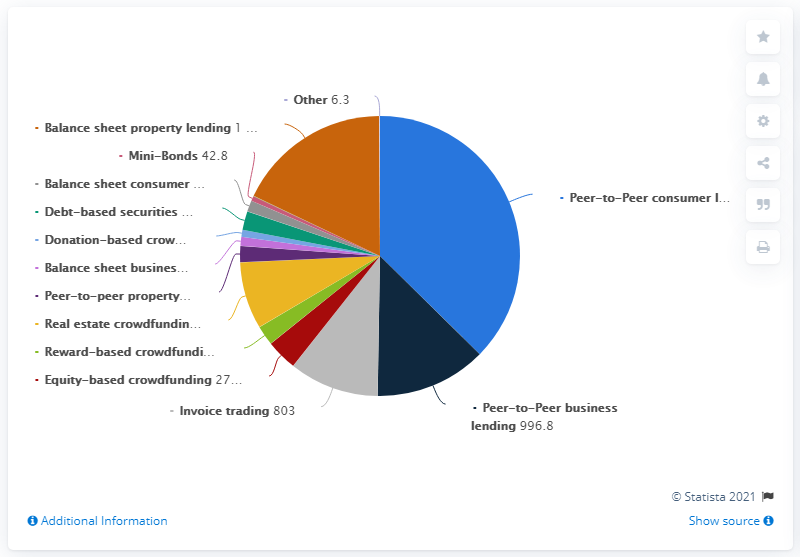Give some essential details in this illustration. The total value of transactions in 2018 was 2889.4. 